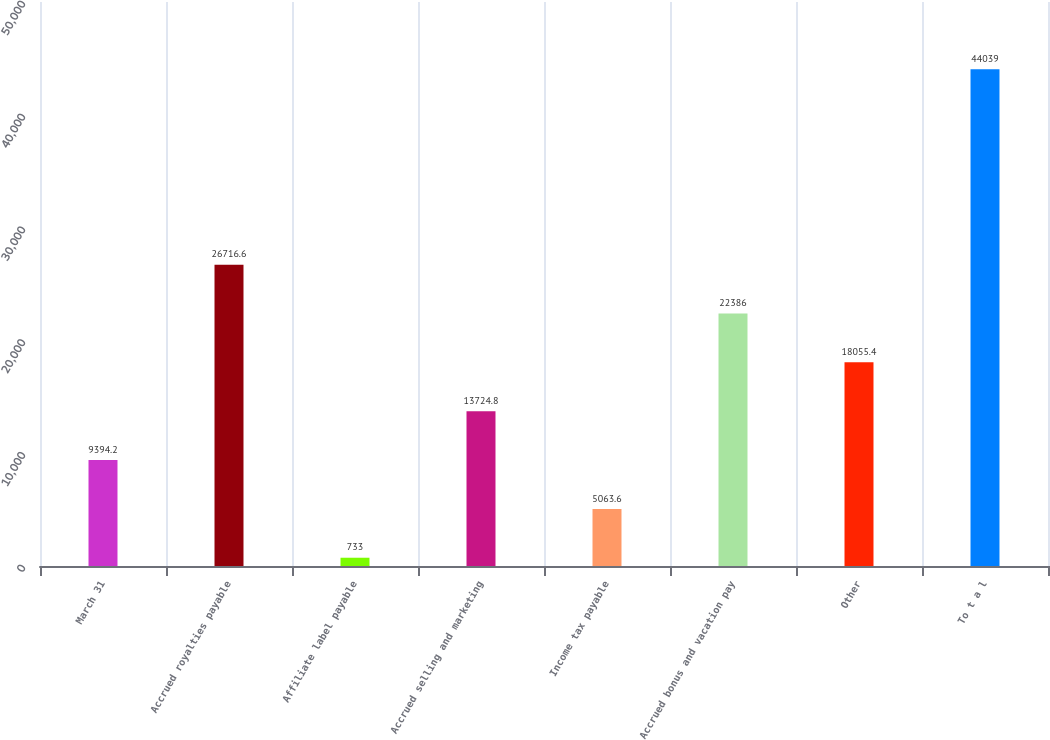Convert chart to OTSL. <chart><loc_0><loc_0><loc_500><loc_500><bar_chart><fcel>March 31<fcel>Accrued royalties payable<fcel>Affiliate label payable<fcel>Accrued selling and marketing<fcel>Income tax payable<fcel>Accrued bonus and vacation pay<fcel>Other<fcel>To t a l<nl><fcel>9394.2<fcel>26716.6<fcel>733<fcel>13724.8<fcel>5063.6<fcel>22386<fcel>18055.4<fcel>44039<nl></chart> 